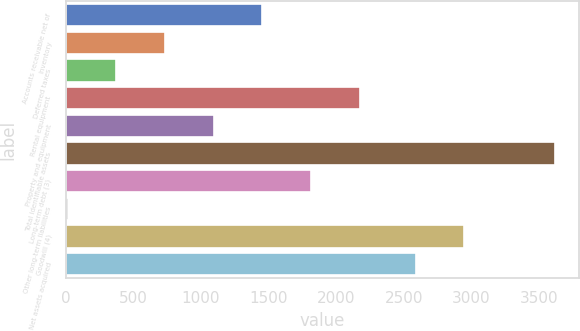Convert chart. <chart><loc_0><loc_0><loc_500><loc_500><bar_chart><fcel>Accounts receivable net of<fcel>Inventory<fcel>Deferred taxes<fcel>Rental equipment<fcel>Property and equipment<fcel>Total identifiable assets<fcel>Long-term debt (3)<fcel>Other long-term liabilities<fcel>Goodwill (4)<fcel>Net assets acquired<nl><fcel>1453.8<fcel>733.4<fcel>373.2<fcel>2174.2<fcel>1093.6<fcel>3615<fcel>1814<fcel>13<fcel>2946.2<fcel>2586<nl></chart> 